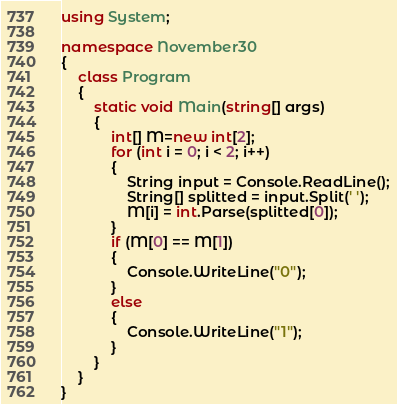Convert code to text. <code><loc_0><loc_0><loc_500><loc_500><_C#_>using System;

namespace November30
{
    class Program
    {
        static void Main(string[] args)
        {
            int[] M=new int[2];
            for (int i = 0; i < 2; i++)
            {
                String input = Console.ReadLine();
                String[] splitted = input.Split(' ');
                M[i] = int.Parse(splitted[0]);
            }
            if (M[0] == M[1])
            {
                Console.WriteLine("0");
            }
            else
            {
                Console.WriteLine("1");
            }
        }
    }
}
</code> 